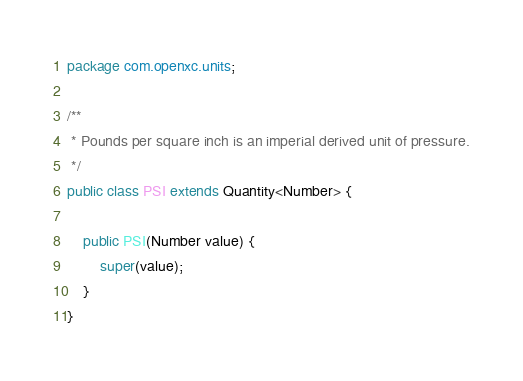<code> <loc_0><loc_0><loc_500><loc_500><_Java_>package com.openxc.units;

/**
 * Pounds per square inch is an imperial derived unit of pressure.
 */
public class PSI extends Quantity<Number> {

    public PSI(Number value) {
        super(value);
    }
}
</code> 